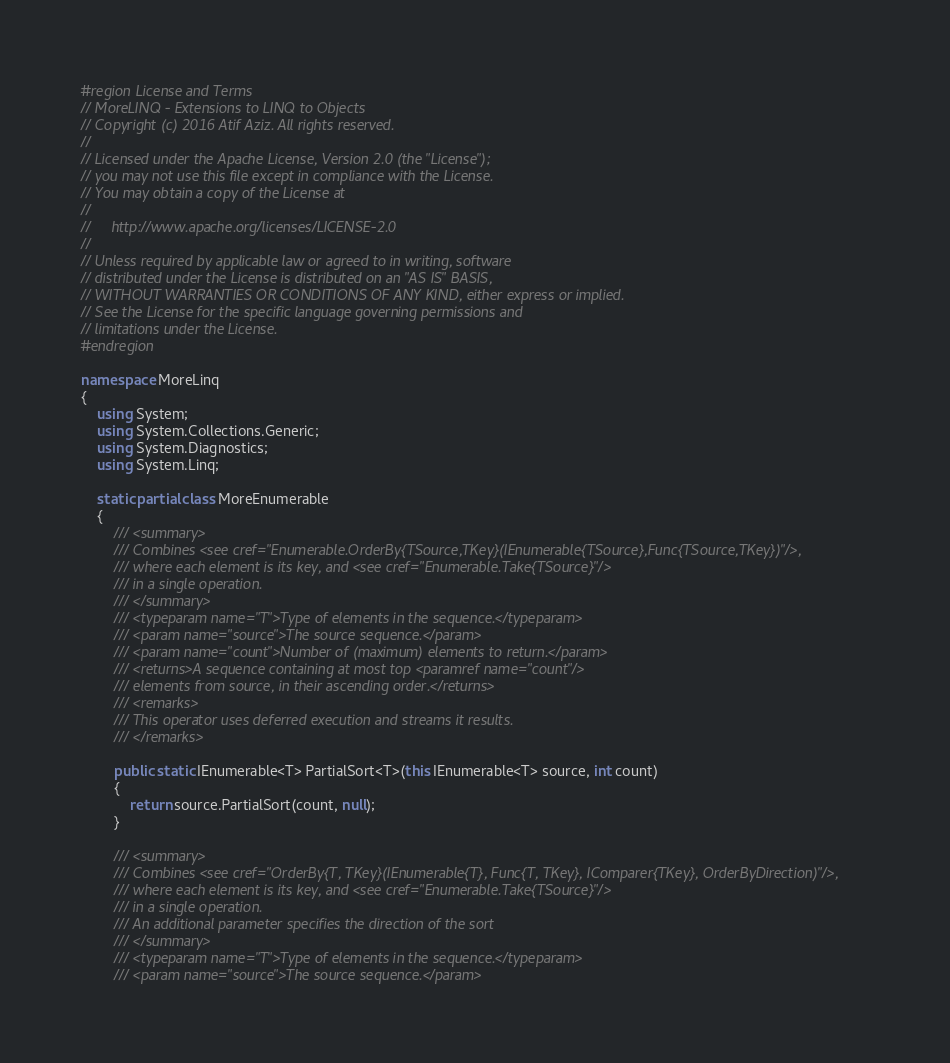Convert code to text. <code><loc_0><loc_0><loc_500><loc_500><_C#_>#region License and Terms
// MoreLINQ - Extensions to LINQ to Objects
// Copyright (c) 2016 Atif Aziz. All rights reserved.
//
// Licensed under the Apache License, Version 2.0 (the "License");
// you may not use this file except in compliance with the License.
// You may obtain a copy of the License at
//
//     http://www.apache.org/licenses/LICENSE-2.0
//
// Unless required by applicable law or agreed to in writing, software
// distributed under the License is distributed on an "AS IS" BASIS,
// WITHOUT WARRANTIES OR CONDITIONS OF ANY KIND, either express or implied.
// See the License for the specific language governing permissions and
// limitations under the License.
#endregion

namespace MoreLinq
{
    using System;
    using System.Collections.Generic;
    using System.Diagnostics;
    using System.Linq;

    static partial class MoreEnumerable
    {
        /// <summary>
        /// Combines <see cref="Enumerable.OrderBy{TSource,TKey}(IEnumerable{TSource},Func{TSource,TKey})"/>,
        /// where each element is its key, and <see cref="Enumerable.Take{TSource}"/>
        /// in a single operation.
        /// </summary>
        /// <typeparam name="T">Type of elements in the sequence.</typeparam>
        /// <param name="source">The source sequence.</param>
        /// <param name="count">Number of (maximum) elements to return.</param>
        /// <returns>A sequence containing at most top <paramref name="count"/>
        /// elements from source, in their ascending order.</returns>
        /// <remarks>
        /// This operator uses deferred execution and streams it results.
        /// </remarks>

        public static IEnumerable<T> PartialSort<T>(this IEnumerable<T> source, int count)
        {
            return source.PartialSort(count, null);
        }

        /// <summary>
        /// Combines <see cref="OrderBy{T, TKey}(IEnumerable{T}, Func{T, TKey}, IComparer{TKey}, OrderByDirection)"/>,
        /// where each element is its key, and <see cref="Enumerable.Take{TSource}"/>
        /// in a single operation.
        /// An additional parameter specifies the direction of the sort
        /// </summary>
        /// <typeparam name="T">Type of elements in the sequence.</typeparam>
        /// <param name="source">The source sequence.</param></code> 